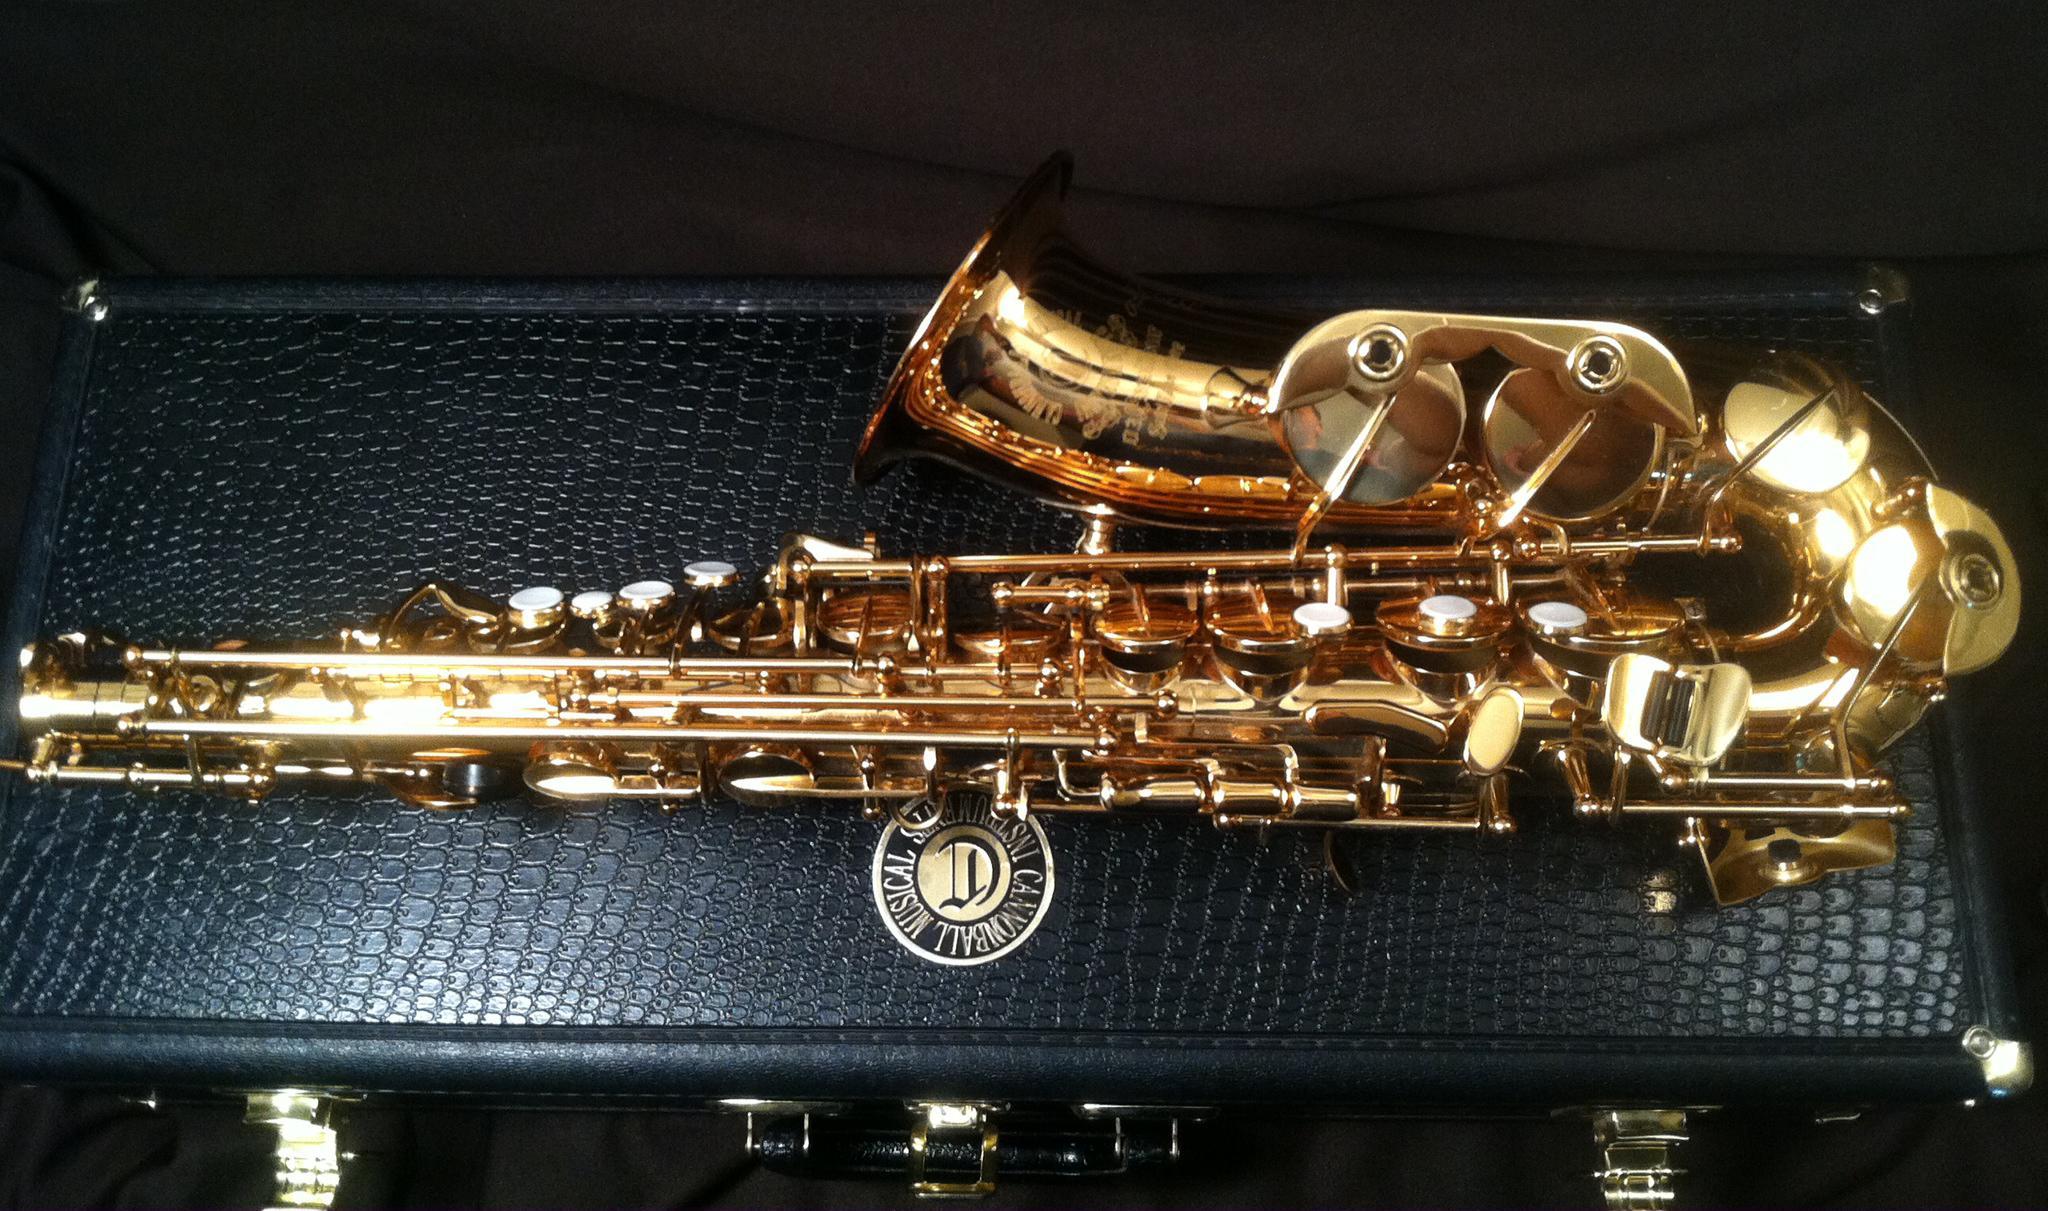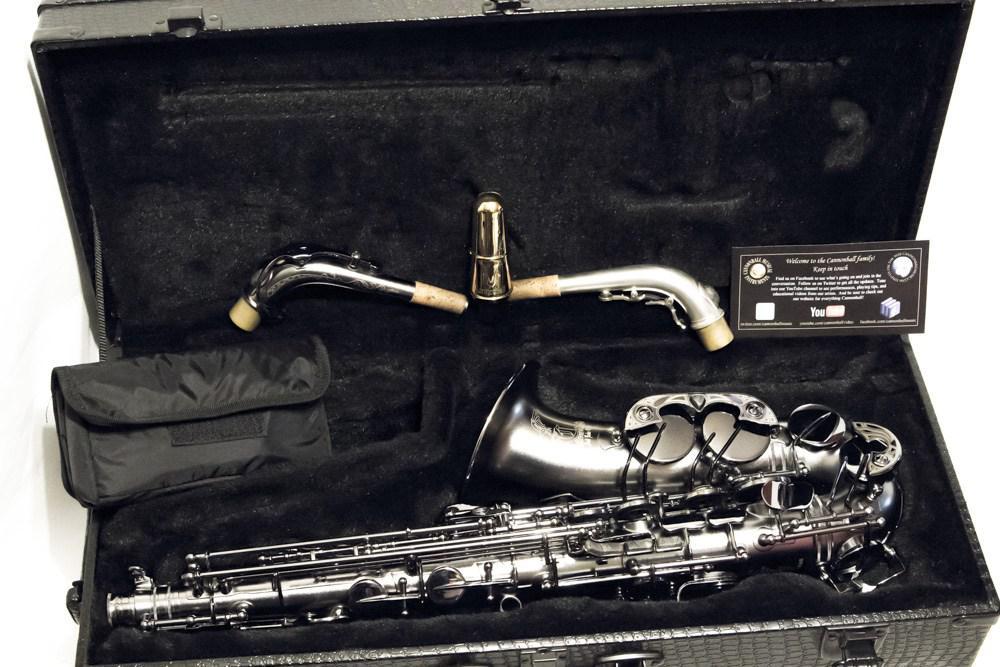The first image is the image on the left, the second image is the image on the right. Considering the images on both sides, is "there is an instrument in its box, the box is lined in velvet and there is a bouch in the box with the instrument" valid? Answer yes or no. Yes. The first image is the image on the left, the second image is the image on the right. Given the left and right images, does the statement "One image shows a saxophone, detached mouthpieces, and a black vinyl pouch in an open case lined with black velvet." hold true? Answer yes or no. Yes. 